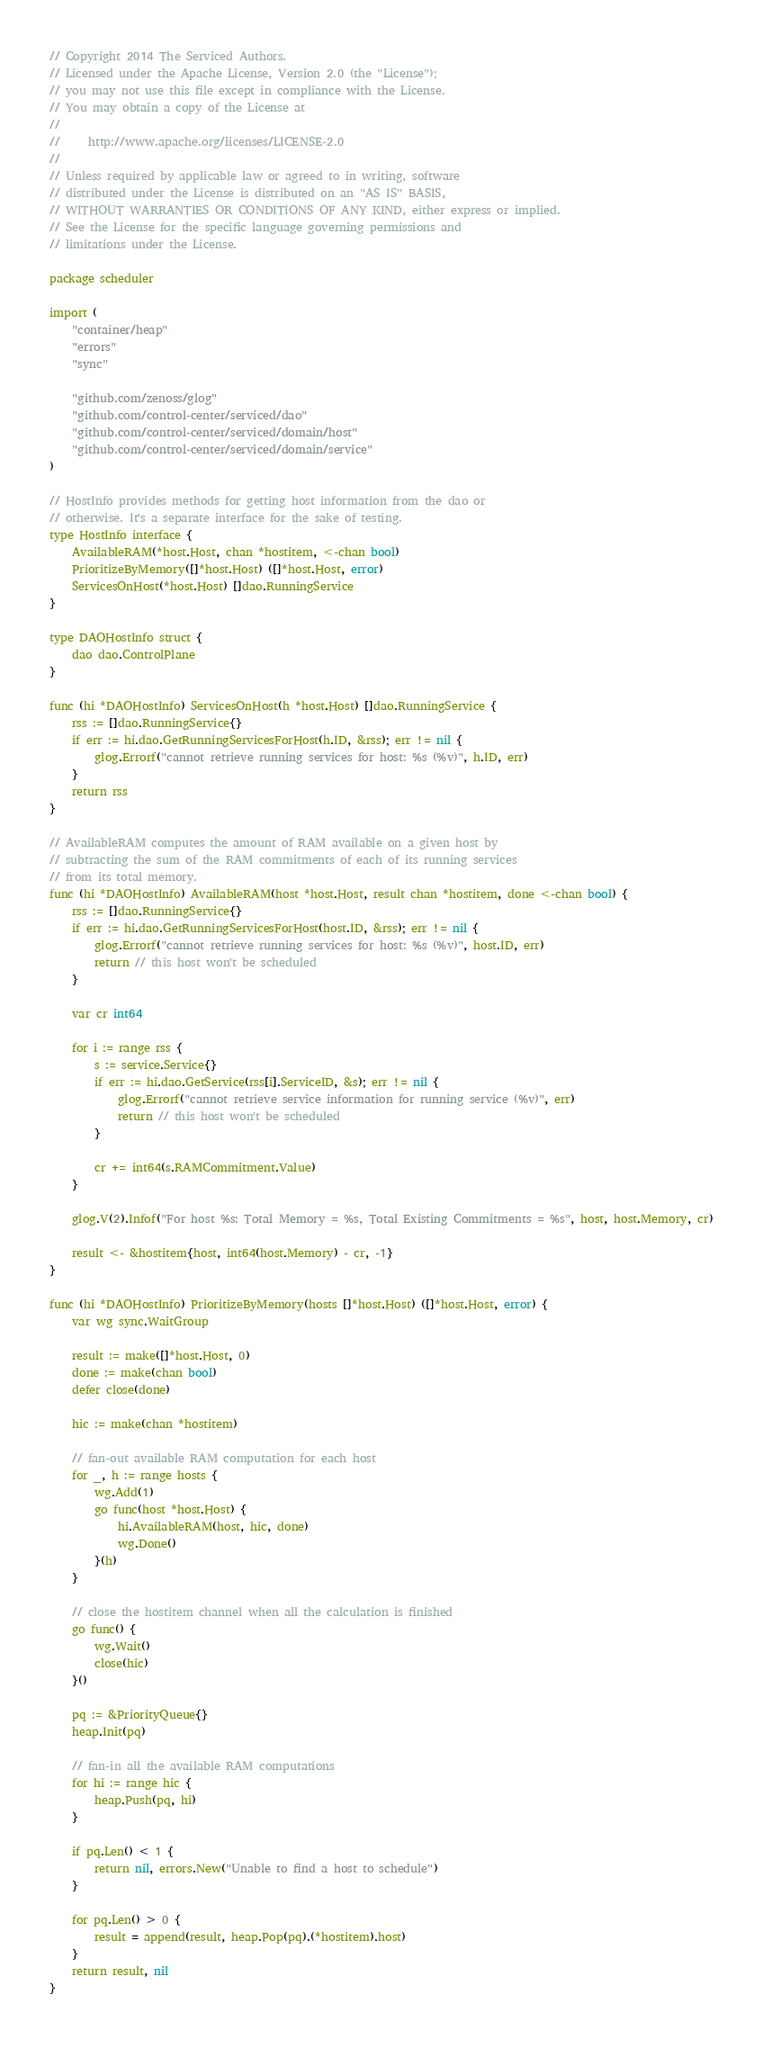<code> <loc_0><loc_0><loc_500><loc_500><_Go_>// Copyright 2014 The Serviced Authors.
// Licensed under the Apache License, Version 2.0 (the "License");
// you may not use this file except in compliance with the License.
// You may obtain a copy of the License at
//
//     http://www.apache.org/licenses/LICENSE-2.0
//
// Unless required by applicable law or agreed to in writing, software
// distributed under the License is distributed on an "AS IS" BASIS,
// WITHOUT WARRANTIES OR CONDITIONS OF ANY KIND, either express or implied.
// See the License for the specific language governing permissions and
// limitations under the License.

package scheduler

import (
	"container/heap"
	"errors"
	"sync"

	"github.com/zenoss/glog"
	"github.com/control-center/serviced/dao"
	"github.com/control-center/serviced/domain/host"
	"github.com/control-center/serviced/domain/service"
)

// HostInfo provides methods for getting host information from the dao or
// otherwise. It's a separate interface for the sake of testing.
type HostInfo interface {
	AvailableRAM(*host.Host, chan *hostitem, <-chan bool)
	PrioritizeByMemory([]*host.Host) ([]*host.Host, error)
	ServicesOnHost(*host.Host) []dao.RunningService
}

type DAOHostInfo struct {
	dao dao.ControlPlane
}

func (hi *DAOHostInfo) ServicesOnHost(h *host.Host) []dao.RunningService {
	rss := []dao.RunningService{}
	if err := hi.dao.GetRunningServicesForHost(h.ID, &rss); err != nil {
		glog.Errorf("cannot retrieve running services for host: %s (%v)", h.ID, err)
	}
	return rss
}

// AvailableRAM computes the amount of RAM available on a given host by
// subtracting the sum of the RAM commitments of each of its running services
// from its total memory.
func (hi *DAOHostInfo) AvailableRAM(host *host.Host, result chan *hostitem, done <-chan bool) {
	rss := []dao.RunningService{}
	if err := hi.dao.GetRunningServicesForHost(host.ID, &rss); err != nil {
		glog.Errorf("cannot retrieve running services for host: %s (%v)", host.ID, err)
		return // this host won't be scheduled
	}

	var cr int64

	for i := range rss {
		s := service.Service{}
		if err := hi.dao.GetService(rss[i].ServiceID, &s); err != nil {
			glog.Errorf("cannot retrieve service information for running service (%v)", err)
			return // this host won't be scheduled
		}

		cr += int64(s.RAMCommitment.Value)
	}

	glog.V(2).Infof("For host %s: Total Memory = %s, Total Existing Commitments = %s", host, host.Memory, cr)

	result <- &hostitem{host, int64(host.Memory) - cr, -1}
}

func (hi *DAOHostInfo) PrioritizeByMemory(hosts []*host.Host) ([]*host.Host, error) {
	var wg sync.WaitGroup

	result := make([]*host.Host, 0)
	done := make(chan bool)
	defer close(done)

	hic := make(chan *hostitem)

	// fan-out available RAM computation for each host
	for _, h := range hosts {
		wg.Add(1)
		go func(host *host.Host) {
			hi.AvailableRAM(host, hic, done)
			wg.Done()
		}(h)
	}

	// close the hostitem channel when all the calculation is finished
	go func() {
		wg.Wait()
		close(hic)
	}()

	pq := &PriorityQueue{}
	heap.Init(pq)

	// fan-in all the available RAM computations
	for hi := range hic {
		heap.Push(pq, hi)
	}

	if pq.Len() < 1 {
		return nil, errors.New("Unable to find a host to schedule")
	}

	for pq.Len() > 0 {
		result = append(result, heap.Pop(pq).(*hostitem).host)
	}
	return result, nil
}
</code> 